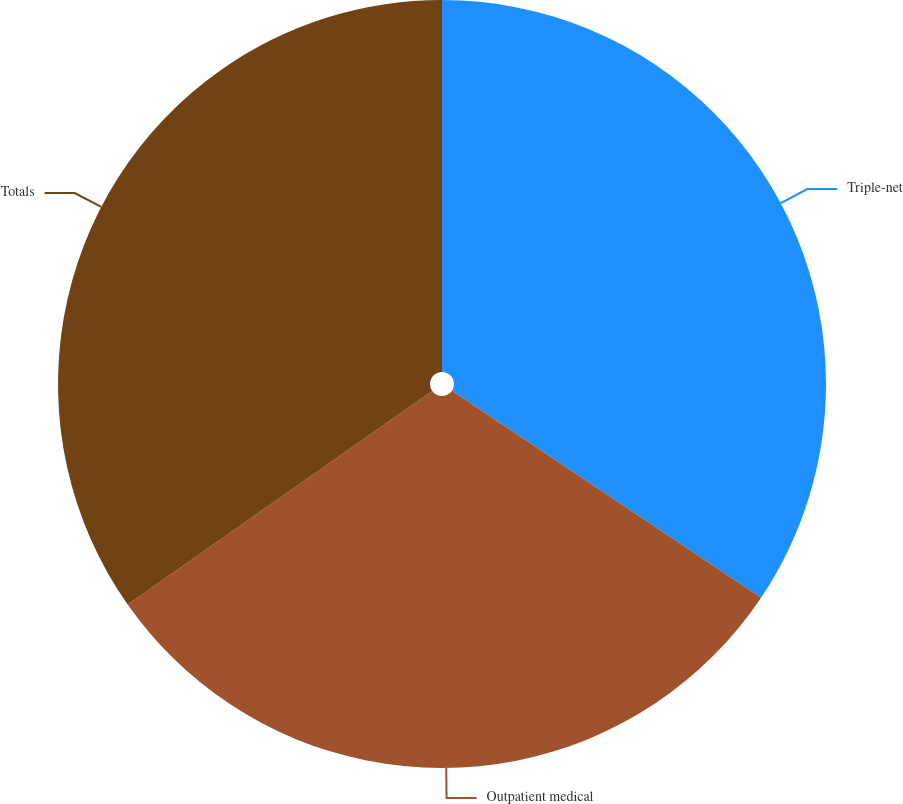Convert chart to OTSL. <chart><loc_0><loc_0><loc_500><loc_500><pie_chart><fcel>Triple-net<fcel>Outpatient medical<fcel>Totals<nl><fcel>34.39%<fcel>30.87%<fcel>34.74%<nl></chart> 